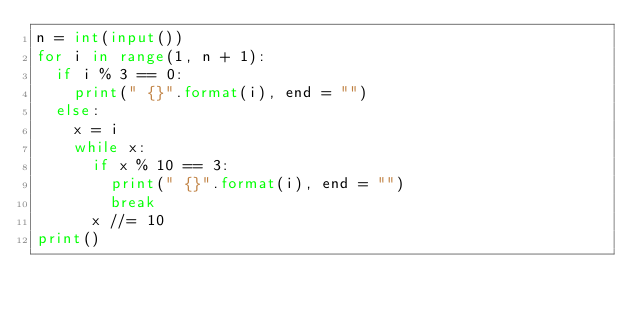<code> <loc_0><loc_0><loc_500><loc_500><_Python_>n = int(input())
for i in range(1, n + 1):
  if i % 3 == 0:
    print(" {}".format(i), end = "")
  else:
    x = i
    while x:
      if x % 10 == 3:
        print(" {}".format(i), end = "")
        break
      x //= 10
print()
</code> 